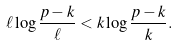<formula> <loc_0><loc_0><loc_500><loc_500>\ell \log { \frac { p - k } { \ell } } < k \log { \frac { p - k } { k } } .</formula> 